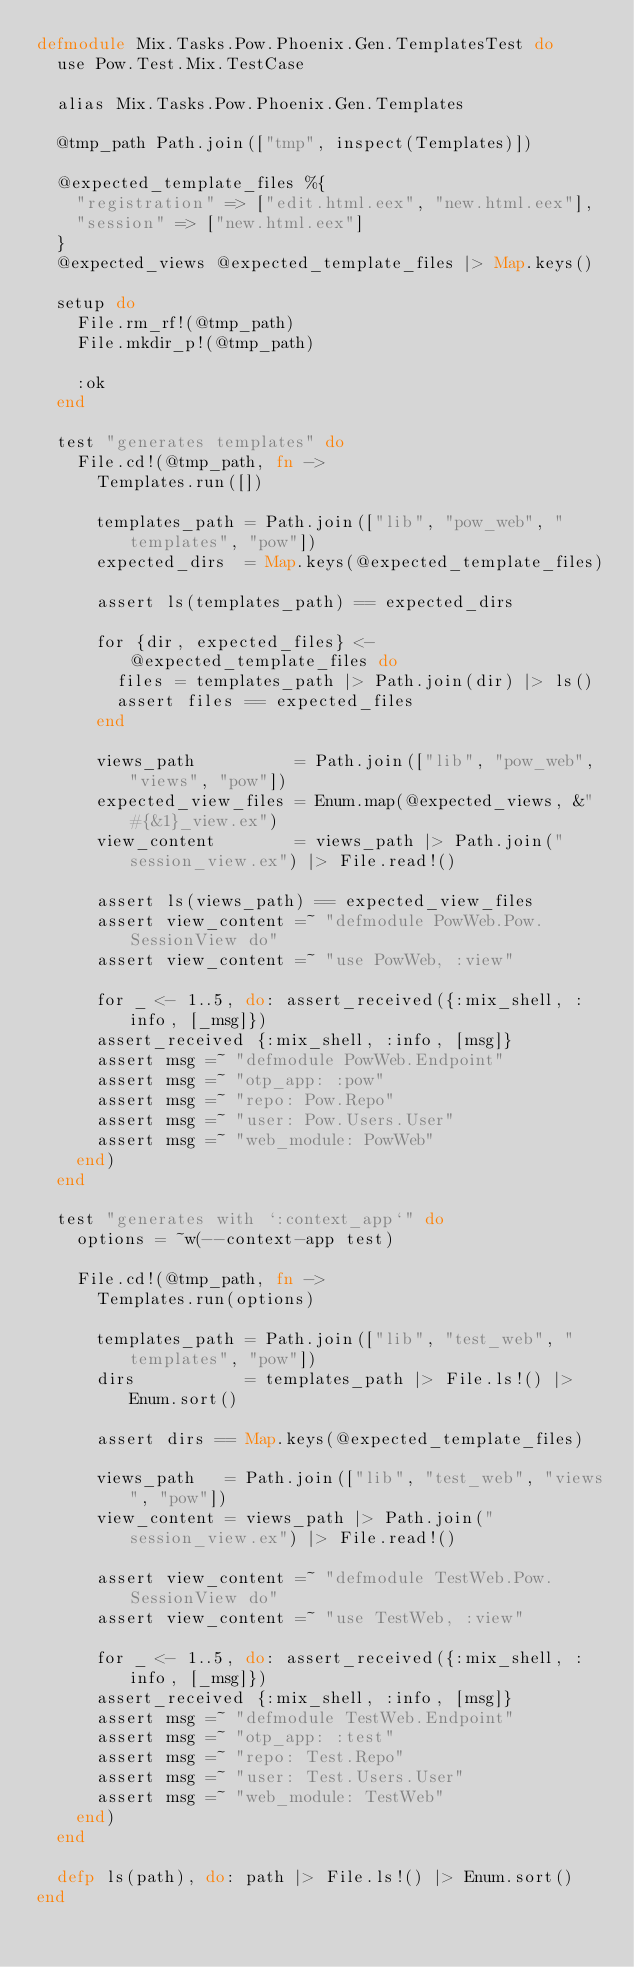<code> <loc_0><loc_0><loc_500><loc_500><_Elixir_>defmodule Mix.Tasks.Pow.Phoenix.Gen.TemplatesTest do
  use Pow.Test.Mix.TestCase

  alias Mix.Tasks.Pow.Phoenix.Gen.Templates

  @tmp_path Path.join(["tmp", inspect(Templates)])

  @expected_template_files %{
    "registration" => ["edit.html.eex", "new.html.eex"],
    "session" => ["new.html.eex"]
  }
  @expected_views @expected_template_files |> Map.keys()

  setup do
    File.rm_rf!(@tmp_path)
    File.mkdir_p!(@tmp_path)

    :ok
  end

  test "generates templates" do
    File.cd!(@tmp_path, fn ->
      Templates.run([])

      templates_path = Path.join(["lib", "pow_web", "templates", "pow"])
      expected_dirs  = Map.keys(@expected_template_files)

      assert ls(templates_path) == expected_dirs

      for {dir, expected_files} <- @expected_template_files do
        files = templates_path |> Path.join(dir) |> ls()
        assert files == expected_files
      end

      views_path          = Path.join(["lib", "pow_web", "views", "pow"])
      expected_view_files = Enum.map(@expected_views, &"#{&1}_view.ex")
      view_content        = views_path |> Path.join("session_view.ex") |> File.read!()

      assert ls(views_path) == expected_view_files
      assert view_content =~ "defmodule PowWeb.Pow.SessionView do"
      assert view_content =~ "use PowWeb, :view"

      for _ <- 1..5, do: assert_received({:mix_shell, :info, [_msg]})
      assert_received {:mix_shell, :info, [msg]}
      assert msg =~ "defmodule PowWeb.Endpoint"
      assert msg =~ "otp_app: :pow"
      assert msg =~ "repo: Pow.Repo"
      assert msg =~ "user: Pow.Users.User"
      assert msg =~ "web_module: PowWeb"
    end)
  end

  test "generates with `:context_app`" do
    options = ~w(--context-app test)

    File.cd!(@tmp_path, fn ->
      Templates.run(options)

      templates_path = Path.join(["lib", "test_web", "templates", "pow"])
      dirs           = templates_path |> File.ls!() |> Enum.sort()

      assert dirs == Map.keys(@expected_template_files)

      views_path   = Path.join(["lib", "test_web", "views", "pow"])
      view_content = views_path |> Path.join("session_view.ex") |> File.read!()

      assert view_content =~ "defmodule TestWeb.Pow.SessionView do"
      assert view_content =~ "use TestWeb, :view"

      for _ <- 1..5, do: assert_received({:mix_shell, :info, [_msg]})
      assert_received {:mix_shell, :info, [msg]}
      assert msg =~ "defmodule TestWeb.Endpoint"
      assert msg =~ "otp_app: :test"
      assert msg =~ "repo: Test.Repo"
      assert msg =~ "user: Test.Users.User"
      assert msg =~ "web_module: TestWeb"
    end)
  end

  defp ls(path), do: path |> File.ls!() |> Enum.sort()
end
</code> 